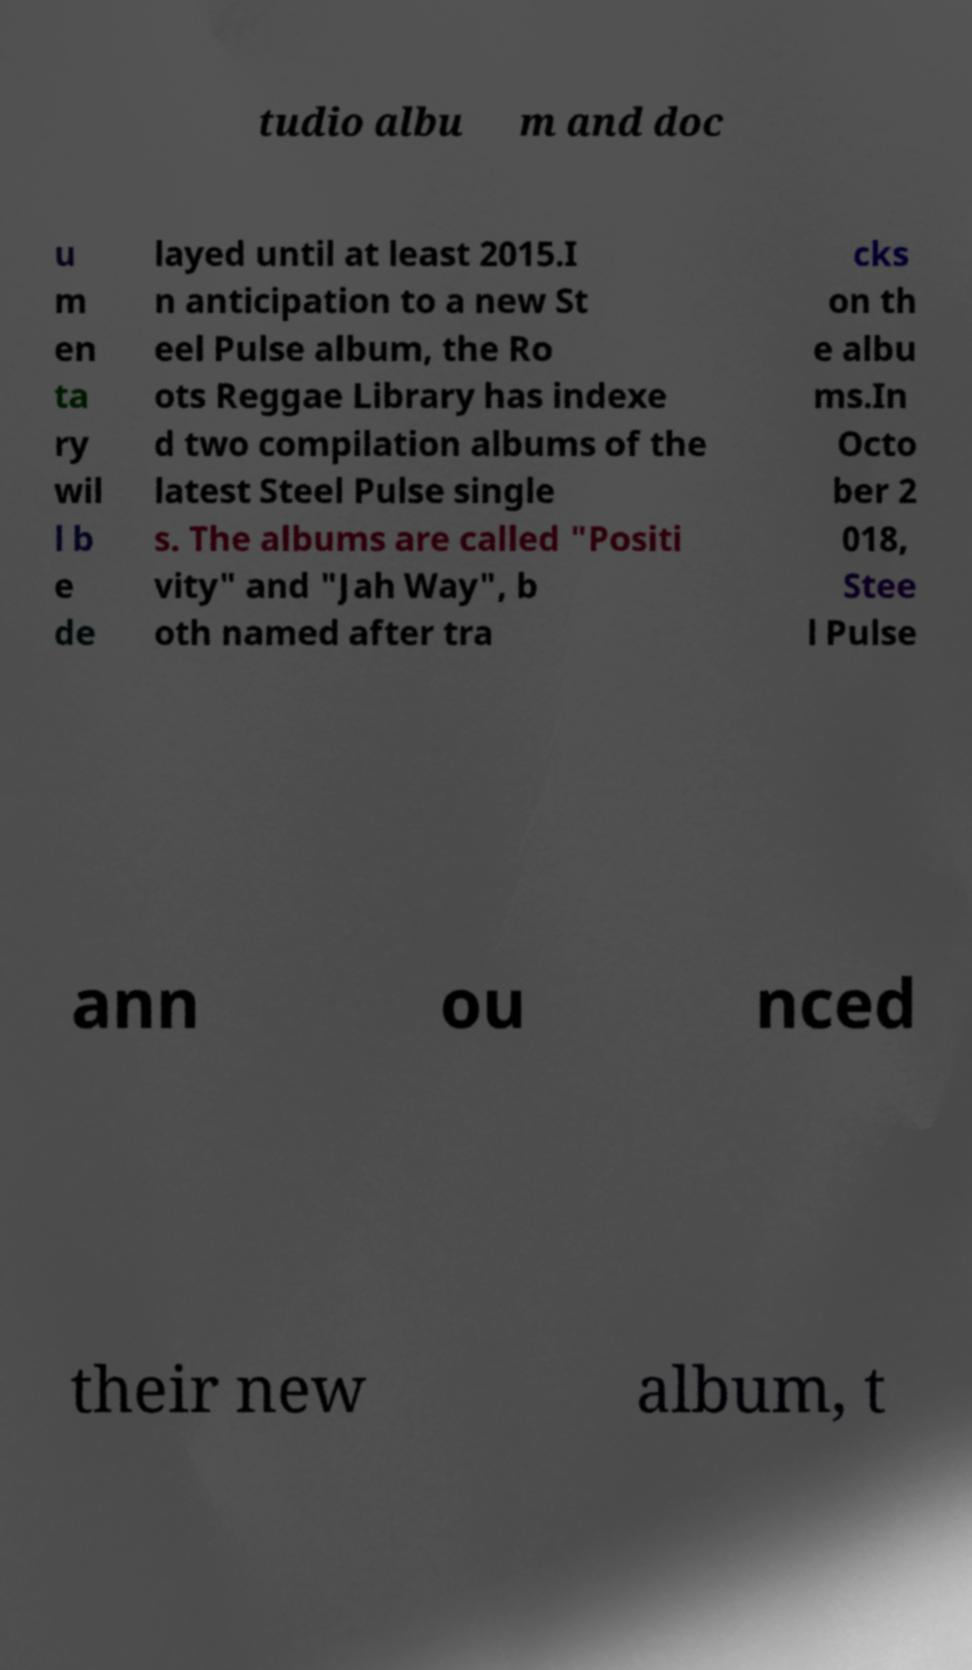Can you accurately transcribe the text from the provided image for me? tudio albu m and doc u m en ta ry wil l b e de layed until at least 2015.I n anticipation to a new St eel Pulse album, the Ro ots Reggae Library has indexe d two compilation albums of the latest Steel Pulse single s. The albums are called "Positi vity" and "Jah Way", b oth named after tra cks on th e albu ms.In Octo ber 2 018, Stee l Pulse ann ou nced their new album, t 